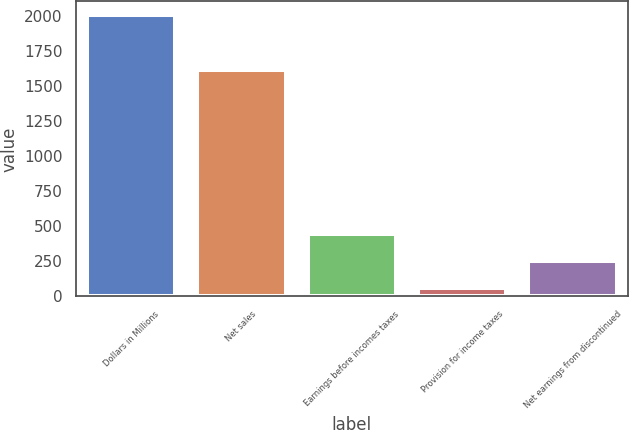Convert chart. <chart><loc_0><loc_0><loc_500><loc_500><bar_chart><fcel>Dollars in Millions<fcel>Net sales<fcel>Earnings before incomes taxes<fcel>Provision for income taxes<fcel>Net earnings from discontinued<nl><fcel>2005<fcel>1617<fcel>448.2<fcel>59<fcel>253.6<nl></chart> 